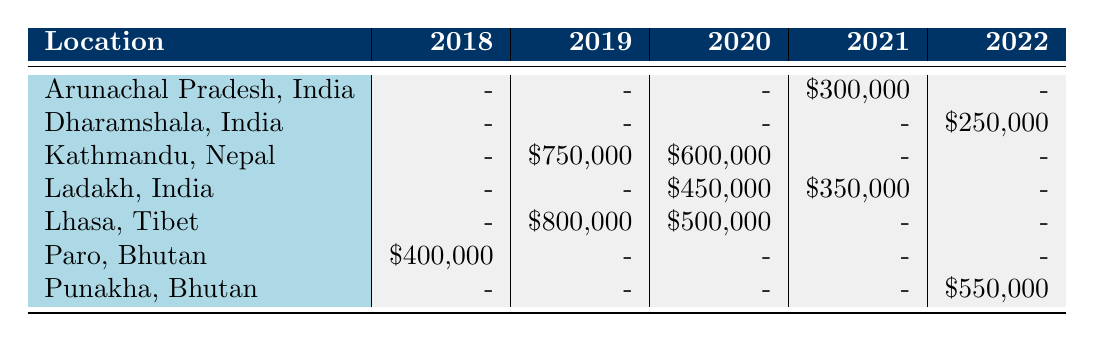What was the funding amount for the restoration of Taktsang Monastery? The table indicates the funding amount for the restoration of Taktsang Monastery is shown in the row corresponding to Paro, Bhutan, with the year 2018 listed beside it. The amount is listed as $400,000.
Answer: 400000 Which location received the highest funding in 2019? In the table, we look at the 2019 column. The funding amounts for each location in that year are: Kathmandu, Nepal - $750,000; Lhasa, Tibet - $800,000. The highest amount is $800,000 for Lhasa, Tibet.
Answer: Lhasa, Tibet Is there any project in Ladakh, India, funded in 2022? By examining the table for the 2022 column under the location Ladakh, India, we see that there is no entry, indicating there were no projects funded there in that year.
Answer: No What is the total funding amount for structural repairs across all locations? Reviewing the table, I identify the projects marked as "Structural Repairs": Restoration of Potala Palace ($500,000) and Swayambhunath Stupa ($600,000). The total is calculated by summing these amounts: $500,000 + $600,000 = $1,100,000.
Answer: 1100000 How many different funding sources are represented in the table? By inspecting the projects listed, we note the unique funding sources, which include: UNESCO World Heritage Fund, Asian Development Bank, Indian National Trust for Art and Cultural Heritage, Bhutan Foundation, Tibetan Government-in-Exile, Nepal Tourism Board, Archaeological Survey of India, China National Arts Fund, Japan International Cooperation Agency, and World Monuments Fund. This gives us a total of 10 unique funding sources.
Answer: 10 